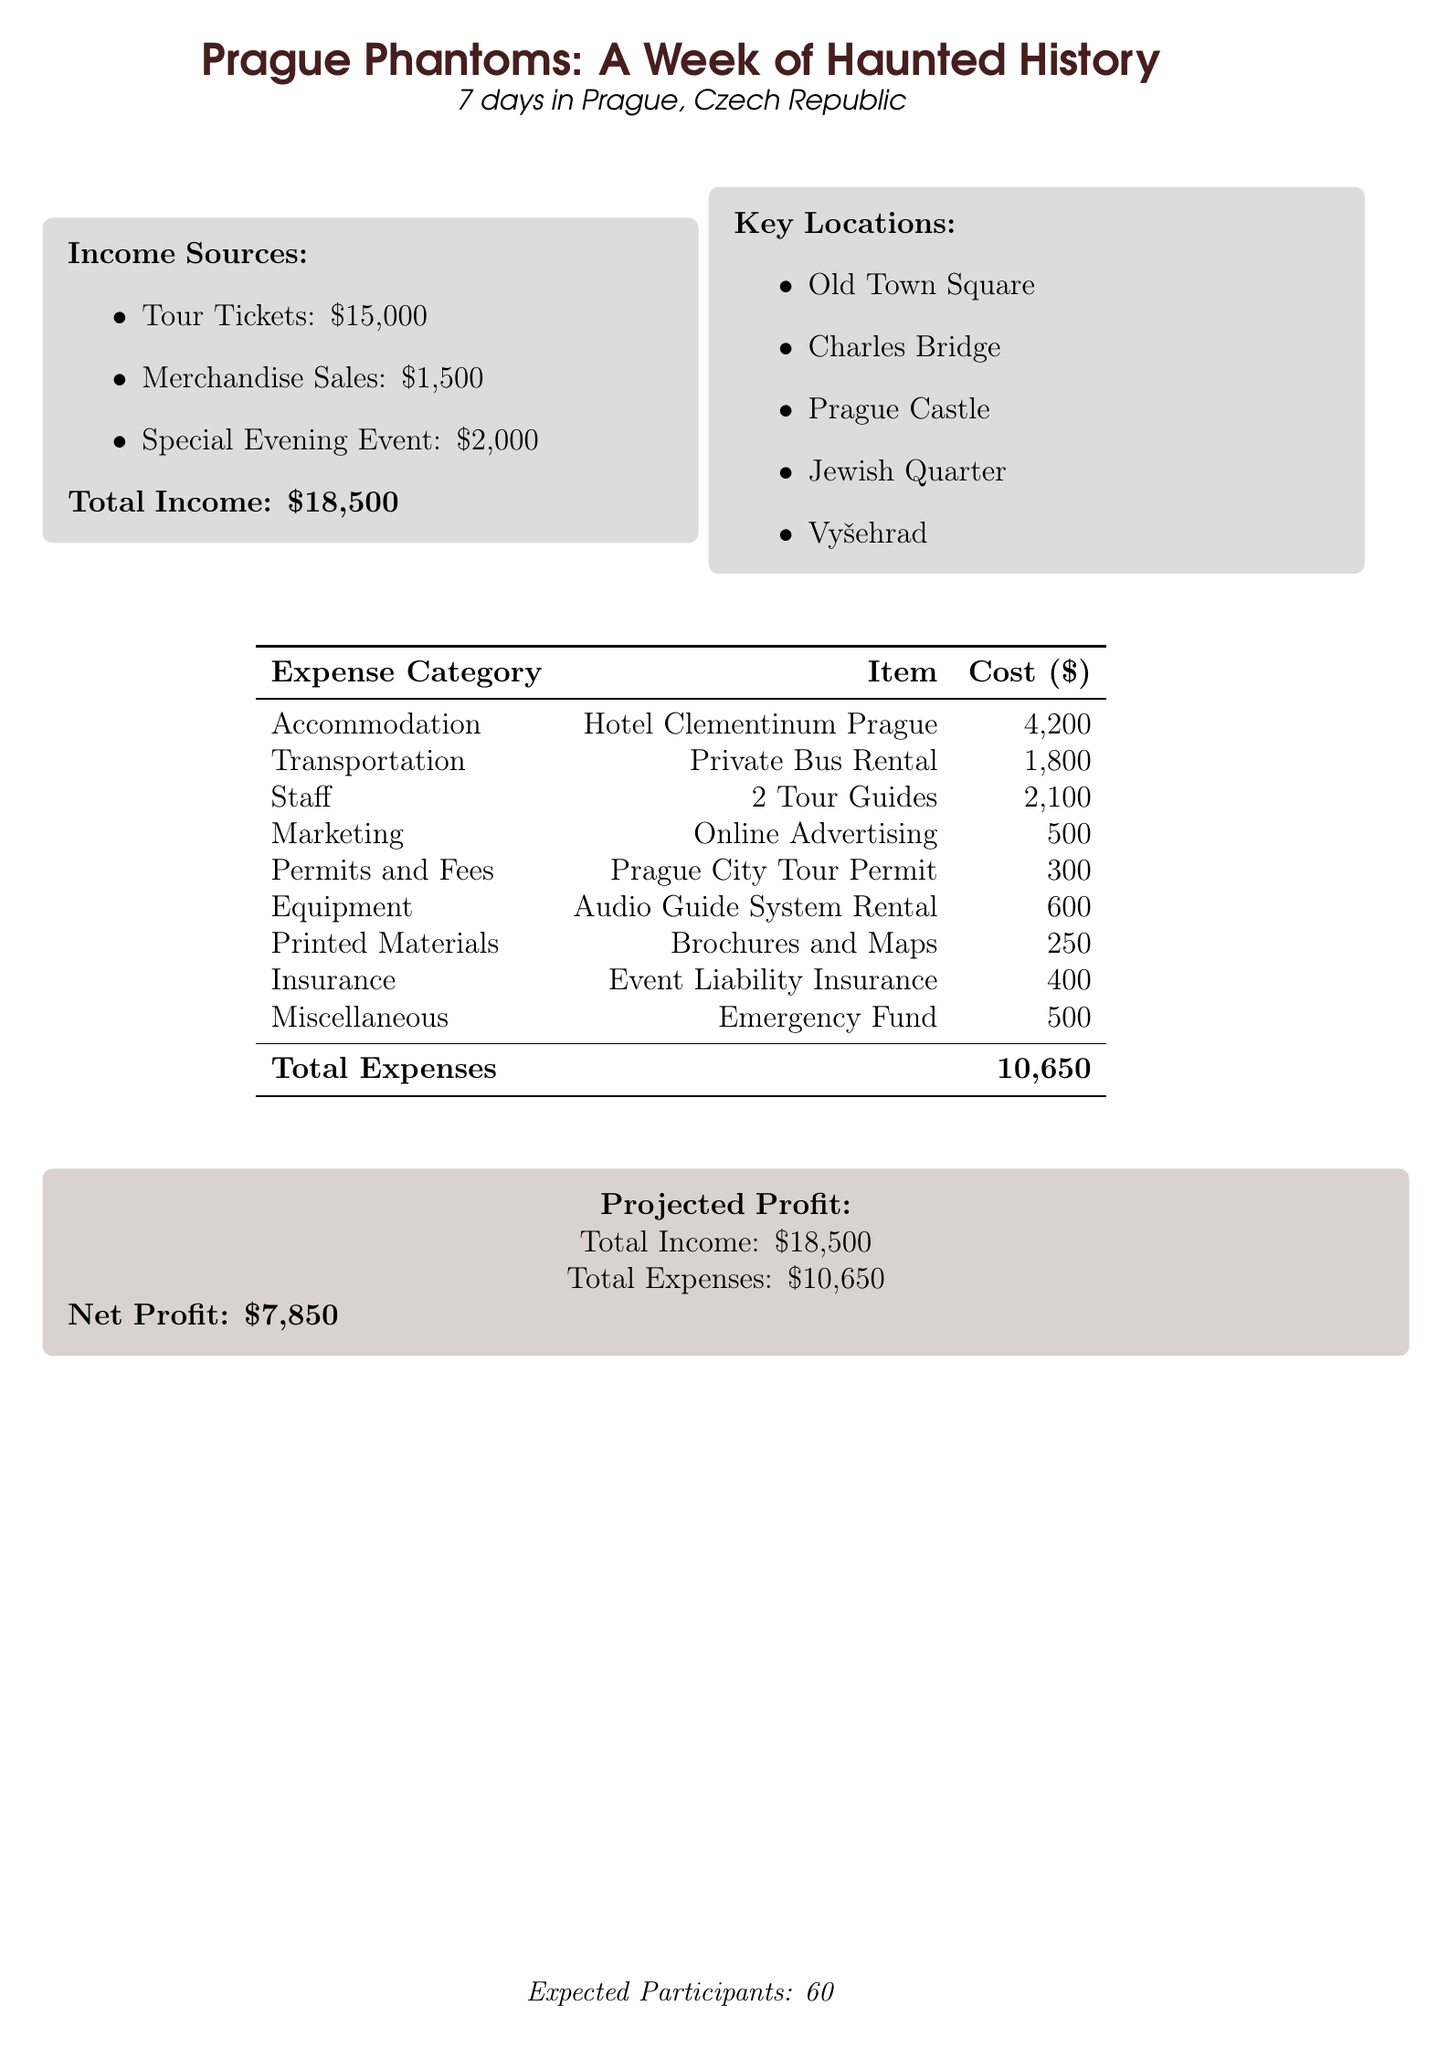what is the total income? The total income is the sum of all income sources in the document, which is $15,000 + $1,500 + $2,000 = $18,500.
Answer: $18,500 how much is allocated for transportation? The allocated amount for transportation is detailed in the expenses section of the document. The private bus rental costs $1,800.
Answer: $1,800 how many tour guides are included in the staff category? The document specifies that there are 2 tour guides included in the staff category.
Answer: 2 what is the cost of event liability insurance? The cost for event liability insurance is explicitly stated in the expenses section of the document. It is $400.
Answer: $400 what is the projected profit for the event? The projected profit is derived from total income minus total expenses, which is $18,500 - $10,650 = $7,850.
Answer: $7,850 which location is listed first under key locations? The first location mentioned in the key locations section is Old Town Square.
Answer: Old Town Square how much is allocated for marketing in the budget? The marketing category lists online advertising with a cost of $500.
Answer: $500 what is the total number of expected participants? The expected number of participants is stated at the bottom of the document. It is 60.
Answer: 60 how much is the special evening event expected to generate? The expected income from the special evening event is noted in the income sources. It is $2,000.
Answer: $2,000 which item has the highest cost in the expense category? The highest cost in the expense category is accommodation, specifically for Hotel Clementinum Prague, which costs $4,200.
Answer: $4,200 